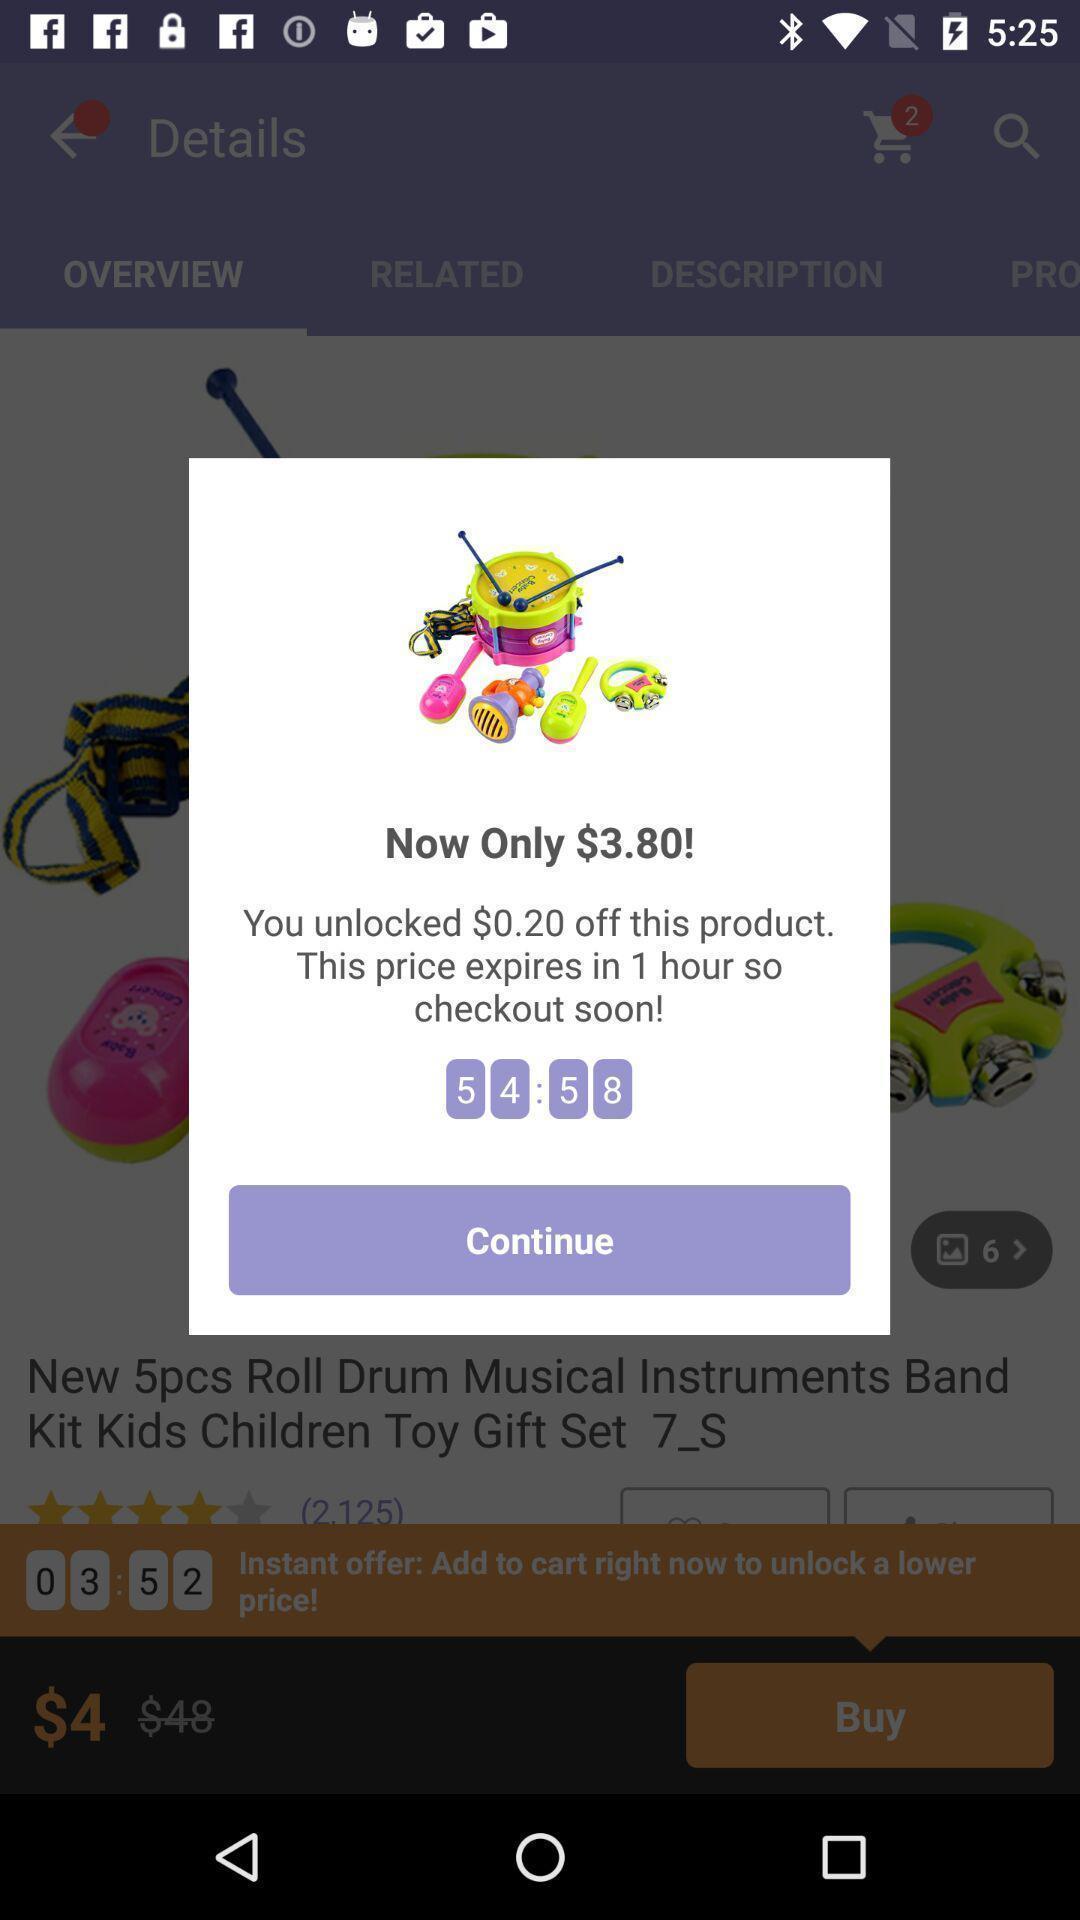Explain what's happening in this screen capture. Pop-up showing offer price of the product. 